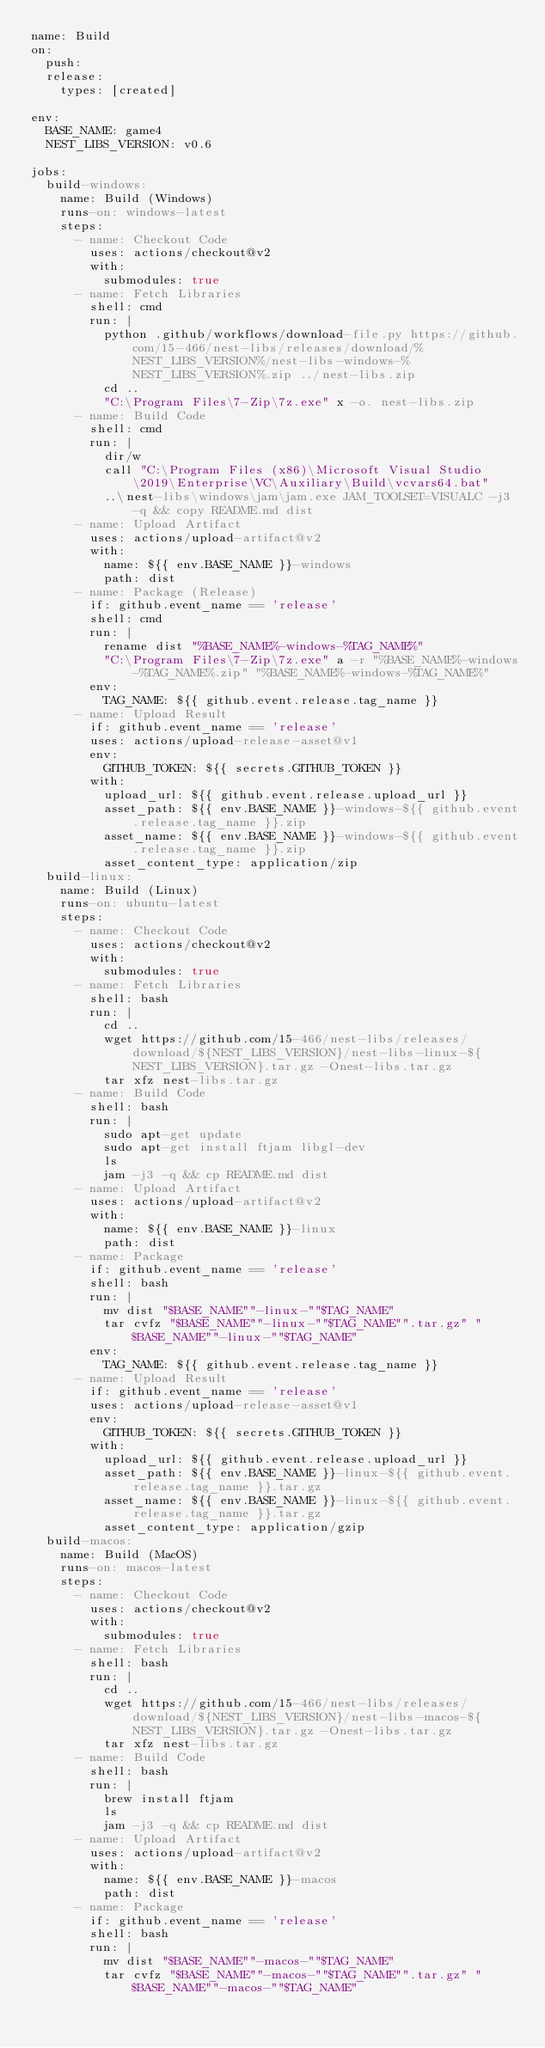Convert code to text. <code><loc_0><loc_0><loc_500><loc_500><_YAML_>name: Build
on:
  push:
  release:
    types: [created]

env:
  BASE_NAME: game4
  NEST_LIBS_VERSION: v0.6

jobs:
  build-windows:
    name: Build (Windows)
    runs-on: windows-latest
    steps:
      - name: Checkout Code
        uses: actions/checkout@v2
        with:
          submodules: true
      - name: Fetch Libraries
        shell: cmd
        run: |
          python .github/workflows/download-file.py https://github.com/15-466/nest-libs/releases/download/%NEST_LIBS_VERSION%/nest-libs-windows-%NEST_LIBS_VERSION%.zip ../nest-libs.zip
          cd ..
          "C:\Program Files\7-Zip\7z.exe" x -o. nest-libs.zip
      - name: Build Code
        shell: cmd
        run: |
          dir/w
          call "C:\Program Files (x86)\Microsoft Visual Studio\2019\Enterprise\VC\Auxiliary\Build\vcvars64.bat"
          ..\nest-libs\windows\jam\jam.exe JAM_TOOLSET=VISUALC -j3 -q && copy README.md dist
      - name: Upload Artifact
        uses: actions/upload-artifact@v2
        with:
          name: ${{ env.BASE_NAME }}-windows
          path: dist
      - name: Package (Release)
        if: github.event_name == 'release'
        shell: cmd
        run: |
          rename dist "%BASE_NAME%-windows-%TAG_NAME%"
          "C:\Program Files\7-Zip\7z.exe" a -r "%BASE_NAME%-windows-%TAG_NAME%.zip" "%BASE_NAME%-windows-%TAG_NAME%"
        env:
          TAG_NAME: ${{ github.event.release.tag_name }}
      - name: Upload Result
        if: github.event_name == 'release'
        uses: actions/upload-release-asset@v1
        env:
          GITHUB_TOKEN: ${{ secrets.GITHUB_TOKEN }}
        with:
          upload_url: ${{ github.event.release.upload_url }}
          asset_path: ${{ env.BASE_NAME }}-windows-${{ github.event.release.tag_name }}.zip
          asset_name: ${{ env.BASE_NAME }}-windows-${{ github.event.release.tag_name }}.zip
          asset_content_type: application/zip
  build-linux:
    name: Build (Linux)
    runs-on: ubuntu-latest
    steps:
      - name: Checkout Code
        uses: actions/checkout@v2
        with:
          submodules: true
      - name: Fetch Libraries
        shell: bash
        run: |
          cd ..
          wget https://github.com/15-466/nest-libs/releases/download/${NEST_LIBS_VERSION}/nest-libs-linux-${NEST_LIBS_VERSION}.tar.gz -Onest-libs.tar.gz
          tar xfz nest-libs.tar.gz
      - name: Build Code
        shell: bash
        run: |
          sudo apt-get update
          sudo apt-get install ftjam libgl-dev
          ls
          jam -j3 -q && cp README.md dist
      - name: Upload Artifact
        uses: actions/upload-artifact@v2
        with:
          name: ${{ env.BASE_NAME }}-linux
          path: dist
      - name: Package
        if: github.event_name == 'release'
        shell: bash
        run: |
          mv dist "$BASE_NAME""-linux-""$TAG_NAME"
          tar cvfz "$BASE_NAME""-linux-""$TAG_NAME"".tar.gz" "$BASE_NAME""-linux-""$TAG_NAME"
        env:
          TAG_NAME: ${{ github.event.release.tag_name }}
      - name: Upload Result
        if: github.event_name == 'release'
        uses: actions/upload-release-asset@v1
        env:
          GITHUB_TOKEN: ${{ secrets.GITHUB_TOKEN }}
        with:
          upload_url: ${{ github.event.release.upload_url }}
          asset_path: ${{ env.BASE_NAME }}-linux-${{ github.event.release.tag_name }}.tar.gz
          asset_name: ${{ env.BASE_NAME }}-linux-${{ github.event.release.tag_name }}.tar.gz
          asset_content_type: application/gzip
  build-macos:
    name: Build (MacOS)
    runs-on: macos-latest
    steps:
      - name: Checkout Code
        uses: actions/checkout@v2
        with:
          submodules: true
      - name: Fetch Libraries
        shell: bash
        run: |
          cd ..
          wget https://github.com/15-466/nest-libs/releases/download/${NEST_LIBS_VERSION}/nest-libs-macos-${NEST_LIBS_VERSION}.tar.gz -Onest-libs.tar.gz
          tar xfz nest-libs.tar.gz
      - name: Build Code
        shell: bash
        run: |
          brew install ftjam
          ls
          jam -j3 -q && cp README.md dist
      - name: Upload Artifact
        uses: actions/upload-artifact@v2
        with:
          name: ${{ env.BASE_NAME }}-macos
          path: dist
      - name: Package
        if: github.event_name == 'release'
        shell: bash
        run: |
          mv dist "$BASE_NAME""-macos-""$TAG_NAME"
          tar cvfz "$BASE_NAME""-macos-""$TAG_NAME"".tar.gz" "$BASE_NAME""-macos-""$TAG_NAME"</code> 